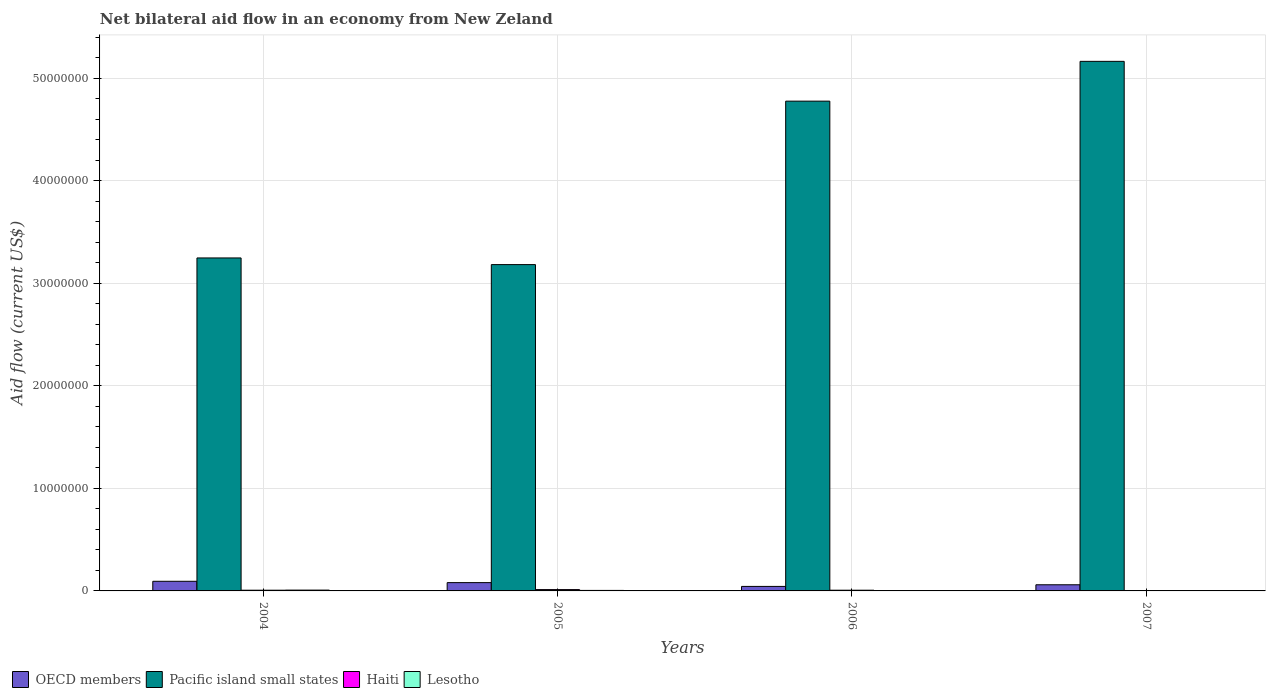How many groups of bars are there?
Make the answer very short. 4. Are the number of bars per tick equal to the number of legend labels?
Ensure brevity in your answer.  Yes. How many bars are there on the 4th tick from the left?
Provide a short and direct response. 4. What is the label of the 4th group of bars from the left?
Provide a short and direct response. 2007. What is the net bilateral aid flow in OECD members in 2007?
Make the answer very short. 6.00e+05. Across all years, what is the maximum net bilateral aid flow in Pacific island small states?
Provide a succinct answer. 5.16e+07. Across all years, what is the minimum net bilateral aid flow in Pacific island small states?
Your answer should be very brief. 3.18e+07. In which year was the net bilateral aid flow in Lesotho maximum?
Give a very brief answer. 2004. In which year was the net bilateral aid flow in Pacific island small states minimum?
Provide a short and direct response. 2005. What is the difference between the net bilateral aid flow in Pacific island small states in 2004 and that in 2007?
Ensure brevity in your answer.  -1.92e+07. What is the average net bilateral aid flow in Haiti per year?
Your answer should be compact. 7.25e+04. In how many years, is the net bilateral aid flow in Lesotho greater than 42000000 US$?
Your answer should be compact. 0. What is the ratio of the net bilateral aid flow in Lesotho in 2006 to that in 2007?
Provide a short and direct response. 0.33. Is the net bilateral aid flow in Pacific island small states in 2004 less than that in 2007?
Your answer should be very brief. Yes. What is the difference between the highest and the lowest net bilateral aid flow in Pacific island small states?
Your answer should be very brief. 1.98e+07. In how many years, is the net bilateral aid flow in Pacific island small states greater than the average net bilateral aid flow in Pacific island small states taken over all years?
Give a very brief answer. 2. What does the 3rd bar from the left in 2007 represents?
Make the answer very short. Haiti. What does the 1st bar from the right in 2006 represents?
Offer a terse response. Lesotho. Are all the bars in the graph horizontal?
Your response must be concise. No. Are the values on the major ticks of Y-axis written in scientific E-notation?
Provide a succinct answer. No. Does the graph contain any zero values?
Make the answer very short. No. Where does the legend appear in the graph?
Keep it short and to the point. Bottom left. What is the title of the graph?
Your response must be concise. Net bilateral aid flow in an economy from New Zeland. Does "Djibouti" appear as one of the legend labels in the graph?
Make the answer very short. No. What is the label or title of the X-axis?
Your response must be concise. Years. What is the label or title of the Y-axis?
Provide a short and direct response. Aid flow (current US$). What is the Aid flow (current US$) in OECD members in 2004?
Give a very brief answer. 9.40e+05. What is the Aid flow (current US$) in Pacific island small states in 2004?
Your answer should be very brief. 3.25e+07. What is the Aid flow (current US$) of OECD members in 2005?
Your response must be concise. 8.10e+05. What is the Aid flow (current US$) in Pacific island small states in 2005?
Your answer should be compact. 3.18e+07. What is the Aid flow (current US$) of Lesotho in 2005?
Provide a short and direct response. 5.00e+04. What is the Aid flow (current US$) of OECD members in 2006?
Your response must be concise. 4.40e+05. What is the Aid flow (current US$) in Pacific island small states in 2006?
Ensure brevity in your answer.  4.78e+07. What is the Aid flow (current US$) of Haiti in 2006?
Provide a succinct answer. 7.00e+04. What is the Aid flow (current US$) in OECD members in 2007?
Provide a succinct answer. 6.00e+05. What is the Aid flow (current US$) of Pacific island small states in 2007?
Give a very brief answer. 5.16e+07. What is the Aid flow (current US$) in Haiti in 2007?
Provide a short and direct response. 2.00e+04. Across all years, what is the maximum Aid flow (current US$) in OECD members?
Your answer should be compact. 9.40e+05. Across all years, what is the maximum Aid flow (current US$) in Pacific island small states?
Your answer should be compact. 5.16e+07. Across all years, what is the maximum Aid flow (current US$) of Lesotho?
Ensure brevity in your answer.  8.00e+04. Across all years, what is the minimum Aid flow (current US$) of Pacific island small states?
Provide a short and direct response. 3.18e+07. Across all years, what is the minimum Aid flow (current US$) in Lesotho?
Ensure brevity in your answer.  10000. What is the total Aid flow (current US$) in OECD members in the graph?
Your answer should be very brief. 2.79e+06. What is the total Aid flow (current US$) in Pacific island small states in the graph?
Ensure brevity in your answer.  1.64e+08. What is the total Aid flow (current US$) of Haiti in the graph?
Offer a very short reply. 2.90e+05. What is the total Aid flow (current US$) in Lesotho in the graph?
Make the answer very short. 1.70e+05. What is the difference between the Aid flow (current US$) in OECD members in 2004 and that in 2005?
Provide a succinct answer. 1.30e+05. What is the difference between the Aid flow (current US$) of Pacific island small states in 2004 and that in 2005?
Keep it short and to the point. 6.50e+05. What is the difference between the Aid flow (current US$) of OECD members in 2004 and that in 2006?
Your answer should be compact. 5.00e+05. What is the difference between the Aid flow (current US$) in Pacific island small states in 2004 and that in 2006?
Give a very brief answer. -1.53e+07. What is the difference between the Aid flow (current US$) of Lesotho in 2004 and that in 2006?
Your answer should be compact. 7.00e+04. What is the difference between the Aid flow (current US$) in OECD members in 2004 and that in 2007?
Keep it short and to the point. 3.40e+05. What is the difference between the Aid flow (current US$) in Pacific island small states in 2004 and that in 2007?
Provide a succinct answer. -1.92e+07. What is the difference between the Aid flow (current US$) in Haiti in 2004 and that in 2007?
Your response must be concise. 5.00e+04. What is the difference between the Aid flow (current US$) in Lesotho in 2004 and that in 2007?
Make the answer very short. 5.00e+04. What is the difference between the Aid flow (current US$) of OECD members in 2005 and that in 2006?
Your answer should be compact. 3.70e+05. What is the difference between the Aid flow (current US$) in Pacific island small states in 2005 and that in 2006?
Give a very brief answer. -1.59e+07. What is the difference between the Aid flow (current US$) in Haiti in 2005 and that in 2006?
Keep it short and to the point. 6.00e+04. What is the difference between the Aid flow (current US$) of Lesotho in 2005 and that in 2006?
Offer a terse response. 4.00e+04. What is the difference between the Aid flow (current US$) of Pacific island small states in 2005 and that in 2007?
Your answer should be very brief. -1.98e+07. What is the difference between the Aid flow (current US$) in Lesotho in 2005 and that in 2007?
Provide a short and direct response. 2.00e+04. What is the difference between the Aid flow (current US$) in Pacific island small states in 2006 and that in 2007?
Provide a short and direct response. -3.88e+06. What is the difference between the Aid flow (current US$) in Lesotho in 2006 and that in 2007?
Keep it short and to the point. -2.00e+04. What is the difference between the Aid flow (current US$) of OECD members in 2004 and the Aid flow (current US$) of Pacific island small states in 2005?
Provide a succinct answer. -3.09e+07. What is the difference between the Aid flow (current US$) of OECD members in 2004 and the Aid flow (current US$) of Haiti in 2005?
Offer a terse response. 8.10e+05. What is the difference between the Aid flow (current US$) of OECD members in 2004 and the Aid flow (current US$) of Lesotho in 2005?
Your answer should be compact. 8.90e+05. What is the difference between the Aid flow (current US$) in Pacific island small states in 2004 and the Aid flow (current US$) in Haiti in 2005?
Ensure brevity in your answer.  3.23e+07. What is the difference between the Aid flow (current US$) of Pacific island small states in 2004 and the Aid flow (current US$) of Lesotho in 2005?
Offer a terse response. 3.24e+07. What is the difference between the Aid flow (current US$) of Haiti in 2004 and the Aid flow (current US$) of Lesotho in 2005?
Ensure brevity in your answer.  2.00e+04. What is the difference between the Aid flow (current US$) in OECD members in 2004 and the Aid flow (current US$) in Pacific island small states in 2006?
Ensure brevity in your answer.  -4.68e+07. What is the difference between the Aid flow (current US$) of OECD members in 2004 and the Aid flow (current US$) of Haiti in 2006?
Provide a short and direct response. 8.70e+05. What is the difference between the Aid flow (current US$) in OECD members in 2004 and the Aid flow (current US$) in Lesotho in 2006?
Your answer should be very brief. 9.30e+05. What is the difference between the Aid flow (current US$) in Pacific island small states in 2004 and the Aid flow (current US$) in Haiti in 2006?
Keep it short and to the point. 3.24e+07. What is the difference between the Aid flow (current US$) in Pacific island small states in 2004 and the Aid flow (current US$) in Lesotho in 2006?
Your answer should be very brief. 3.25e+07. What is the difference between the Aid flow (current US$) of OECD members in 2004 and the Aid flow (current US$) of Pacific island small states in 2007?
Your response must be concise. -5.07e+07. What is the difference between the Aid flow (current US$) of OECD members in 2004 and the Aid flow (current US$) of Haiti in 2007?
Provide a short and direct response. 9.20e+05. What is the difference between the Aid flow (current US$) in OECD members in 2004 and the Aid flow (current US$) in Lesotho in 2007?
Keep it short and to the point. 9.10e+05. What is the difference between the Aid flow (current US$) of Pacific island small states in 2004 and the Aid flow (current US$) of Haiti in 2007?
Provide a succinct answer. 3.24e+07. What is the difference between the Aid flow (current US$) in Pacific island small states in 2004 and the Aid flow (current US$) in Lesotho in 2007?
Your response must be concise. 3.24e+07. What is the difference between the Aid flow (current US$) of OECD members in 2005 and the Aid flow (current US$) of Pacific island small states in 2006?
Provide a short and direct response. -4.70e+07. What is the difference between the Aid flow (current US$) of OECD members in 2005 and the Aid flow (current US$) of Haiti in 2006?
Your response must be concise. 7.40e+05. What is the difference between the Aid flow (current US$) in OECD members in 2005 and the Aid flow (current US$) in Lesotho in 2006?
Your answer should be compact. 8.00e+05. What is the difference between the Aid flow (current US$) in Pacific island small states in 2005 and the Aid flow (current US$) in Haiti in 2006?
Provide a short and direct response. 3.18e+07. What is the difference between the Aid flow (current US$) in Pacific island small states in 2005 and the Aid flow (current US$) in Lesotho in 2006?
Ensure brevity in your answer.  3.18e+07. What is the difference between the Aid flow (current US$) in Haiti in 2005 and the Aid flow (current US$) in Lesotho in 2006?
Make the answer very short. 1.20e+05. What is the difference between the Aid flow (current US$) of OECD members in 2005 and the Aid flow (current US$) of Pacific island small states in 2007?
Your answer should be compact. -5.08e+07. What is the difference between the Aid flow (current US$) of OECD members in 2005 and the Aid flow (current US$) of Haiti in 2007?
Provide a short and direct response. 7.90e+05. What is the difference between the Aid flow (current US$) of OECD members in 2005 and the Aid flow (current US$) of Lesotho in 2007?
Provide a short and direct response. 7.80e+05. What is the difference between the Aid flow (current US$) of Pacific island small states in 2005 and the Aid flow (current US$) of Haiti in 2007?
Provide a succinct answer. 3.18e+07. What is the difference between the Aid flow (current US$) of Pacific island small states in 2005 and the Aid flow (current US$) of Lesotho in 2007?
Provide a succinct answer. 3.18e+07. What is the difference between the Aid flow (current US$) of Haiti in 2005 and the Aid flow (current US$) of Lesotho in 2007?
Make the answer very short. 1.00e+05. What is the difference between the Aid flow (current US$) of OECD members in 2006 and the Aid flow (current US$) of Pacific island small states in 2007?
Ensure brevity in your answer.  -5.12e+07. What is the difference between the Aid flow (current US$) of OECD members in 2006 and the Aid flow (current US$) of Haiti in 2007?
Provide a short and direct response. 4.20e+05. What is the difference between the Aid flow (current US$) in Pacific island small states in 2006 and the Aid flow (current US$) in Haiti in 2007?
Offer a terse response. 4.77e+07. What is the difference between the Aid flow (current US$) of Pacific island small states in 2006 and the Aid flow (current US$) of Lesotho in 2007?
Give a very brief answer. 4.77e+07. What is the difference between the Aid flow (current US$) in Haiti in 2006 and the Aid flow (current US$) in Lesotho in 2007?
Ensure brevity in your answer.  4.00e+04. What is the average Aid flow (current US$) of OECD members per year?
Keep it short and to the point. 6.98e+05. What is the average Aid flow (current US$) of Pacific island small states per year?
Your answer should be compact. 4.09e+07. What is the average Aid flow (current US$) in Haiti per year?
Offer a terse response. 7.25e+04. What is the average Aid flow (current US$) in Lesotho per year?
Keep it short and to the point. 4.25e+04. In the year 2004, what is the difference between the Aid flow (current US$) of OECD members and Aid flow (current US$) of Pacific island small states?
Make the answer very short. -3.15e+07. In the year 2004, what is the difference between the Aid flow (current US$) in OECD members and Aid flow (current US$) in Haiti?
Make the answer very short. 8.70e+05. In the year 2004, what is the difference between the Aid flow (current US$) of OECD members and Aid flow (current US$) of Lesotho?
Give a very brief answer. 8.60e+05. In the year 2004, what is the difference between the Aid flow (current US$) of Pacific island small states and Aid flow (current US$) of Haiti?
Make the answer very short. 3.24e+07. In the year 2004, what is the difference between the Aid flow (current US$) in Pacific island small states and Aid flow (current US$) in Lesotho?
Offer a very short reply. 3.24e+07. In the year 2005, what is the difference between the Aid flow (current US$) in OECD members and Aid flow (current US$) in Pacific island small states?
Your response must be concise. -3.10e+07. In the year 2005, what is the difference between the Aid flow (current US$) in OECD members and Aid flow (current US$) in Haiti?
Provide a short and direct response. 6.80e+05. In the year 2005, what is the difference between the Aid flow (current US$) of OECD members and Aid flow (current US$) of Lesotho?
Ensure brevity in your answer.  7.60e+05. In the year 2005, what is the difference between the Aid flow (current US$) of Pacific island small states and Aid flow (current US$) of Haiti?
Your response must be concise. 3.17e+07. In the year 2005, what is the difference between the Aid flow (current US$) in Pacific island small states and Aid flow (current US$) in Lesotho?
Offer a very short reply. 3.18e+07. In the year 2005, what is the difference between the Aid flow (current US$) of Haiti and Aid flow (current US$) of Lesotho?
Ensure brevity in your answer.  8.00e+04. In the year 2006, what is the difference between the Aid flow (current US$) in OECD members and Aid flow (current US$) in Pacific island small states?
Give a very brief answer. -4.73e+07. In the year 2006, what is the difference between the Aid flow (current US$) of OECD members and Aid flow (current US$) of Haiti?
Provide a short and direct response. 3.70e+05. In the year 2006, what is the difference between the Aid flow (current US$) in OECD members and Aid flow (current US$) in Lesotho?
Ensure brevity in your answer.  4.30e+05. In the year 2006, what is the difference between the Aid flow (current US$) in Pacific island small states and Aid flow (current US$) in Haiti?
Offer a very short reply. 4.77e+07. In the year 2006, what is the difference between the Aid flow (current US$) in Pacific island small states and Aid flow (current US$) in Lesotho?
Make the answer very short. 4.78e+07. In the year 2007, what is the difference between the Aid flow (current US$) in OECD members and Aid flow (current US$) in Pacific island small states?
Your response must be concise. -5.10e+07. In the year 2007, what is the difference between the Aid flow (current US$) in OECD members and Aid flow (current US$) in Haiti?
Keep it short and to the point. 5.80e+05. In the year 2007, what is the difference between the Aid flow (current US$) in OECD members and Aid flow (current US$) in Lesotho?
Your answer should be compact. 5.70e+05. In the year 2007, what is the difference between the Aid flow (current US$) of Pacific island small states and Aid flow (current US$) of Haiti?
Offer a very short reply. 5.16e+07. In the year 2007, what is the difference between the Aid flow (current US$) in Pacific island small states and Aid flow (current US$) in Lesotho?
Offer a terse response. 5.16e+07. What is the ratio of the Aid flow (current US$) of OECD members in 2004 to that in 2005?
Your response must be concise. 1.16. What is the ratio of the Aid flow (current US$) in Pacific island small states in 2004 to that in 2005?
Give a very brief answer. 1.02. What is the ratio of the Aid flow (current US$) of Haiti in 2004 to that in 2005?
Provide a short and direct response. 0.54. What is the ratio of the Aid flow (current US$) in Lesotho in 2004 to that in 2005?
Your response must be concise. 1.6. What is the ratio of the Aid flow (current US$) of OECD members in 2004 to that in 2006?
Give a very brief answer. 2.14. What is the ratio of the Aid flow (current US$) of Pacific island small states in 2004 to that in 2006?
Your answer should be very brief. 0.68. What is the ratio of the Aid flow (current US$) in Haiti in 2004 to that in 2006?
Give a very brief answer. 1. What is the ratio of the Aid flow (current US$) in OECD members in 2004 to that in 2007?
Give a very brief answer. 1.57. What is the ratio of the Aid flow (current US$) in Pacific island small states in 2004 to that in 2007?
Provide a succinct answer. 0.63. What is the ratio of the Aid flow (current US$) of Haiti in 2004 to that in 2007?
Ensure brevity in your answer.  3.5. What is the ratio of the Aid flow (current US$) of Lesotho in 2004 to that in 2007?
Ensure brevity in your answer.  2.67. What is the ratio of the Aid flow (current US$) in OECD members in 2005 to that in 2006?
Your response must be concise. 1.84. What is the ratio of the Aid flow (current US$) in Pacific island small states in 2005 to that in 2006?
Give a very brief answer. 0.67. What is the ratio of the Aid flow (current US$) of Haiti in 2005 to that in 2006?
Provide a succinct answer. 1.86. What is the ratio of the Aid flow (current US$) in OECD members in 2005 to that in 2007?
Your answer should be compact. 1.35. What is the ratio of the Aid flow (current US$) of Pacific island small states in 2005 to that in 2007?
Make the answer very short. 0.62. What is the ratio of the Aid flow (current US$) in Haiti in 2005 to that in 2007?
Offer a terse response. 6.5. What is the ratio of the Aid flow (current US$) of OECD members in 2006 to that in 2007?
Ensure brevity in your answer.  0.73. What is the ratio of the Aid flow (current US$) of Pacific island small states in 2006 to that in 2007?
Provide a short and direct response. 0.92. What is the ratio of the Aid flow (current US$) of Lesotho in 2006 to that in 2007?
Offer a very short reply. 0.33. What is the difference between the highest and the second highest Aid flow (current US$) in Pacific island small states?
Provide a succinct answer. 3.88e+06. What is the difference between the highest and the lowest Aid flow (current US$) in Pacific island small states?
Your answer should be compact. 1.98e+07. What is the difference between the highest and the lowest Aid flow (current US$) of Haiti?
Offer a terse response. 1.10e+05. What is the difference between the highest and the lowest Aid flow (current US$) in Lesotho?
Keep it short and to the point. 7.00e+04. 